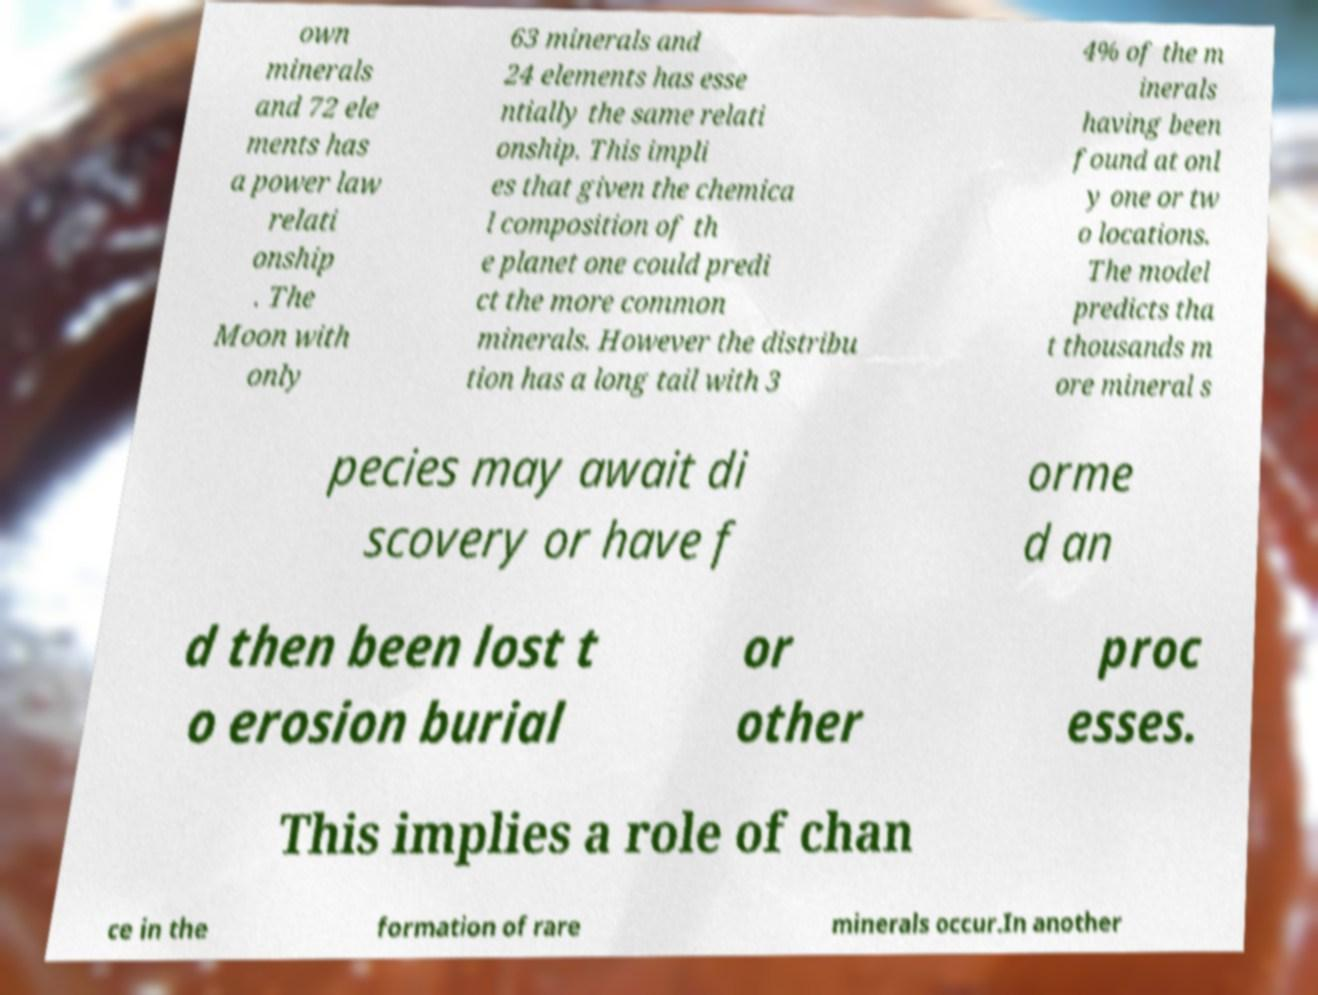Can you accurately transcribe the text from the provided image for me? own minerals and 72 ele ments has a power law relati onship . The Moon with only 63 minerals and 24 elements has esse ntially the same relati onship. This impli es that given the chemica l composition of th e planet one could predi ct the more common minerals. However the distribu tion has a long tail with 3 4% of the m inerals having been found at onl y one or tw o locations. The model predicts tha t thousands m ore mineral s pecies may await di scovery or have f orme d an d then been lost t o erosion burial or other proc esses. This implies a role of chan ce in the formation of rare minerals occur.In another 